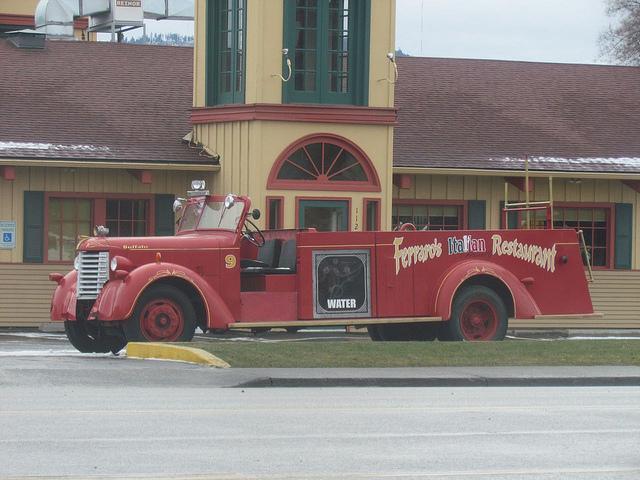How many people are wearing a white hat in a frame?
Give a very brief answer. 0. 